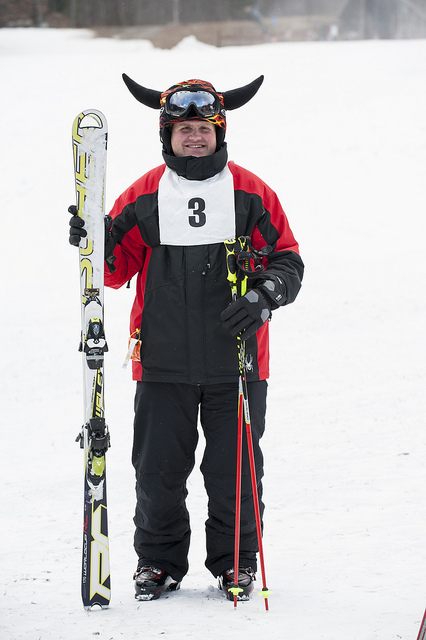Extract all visible text content from this image. 3 